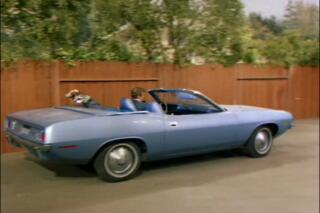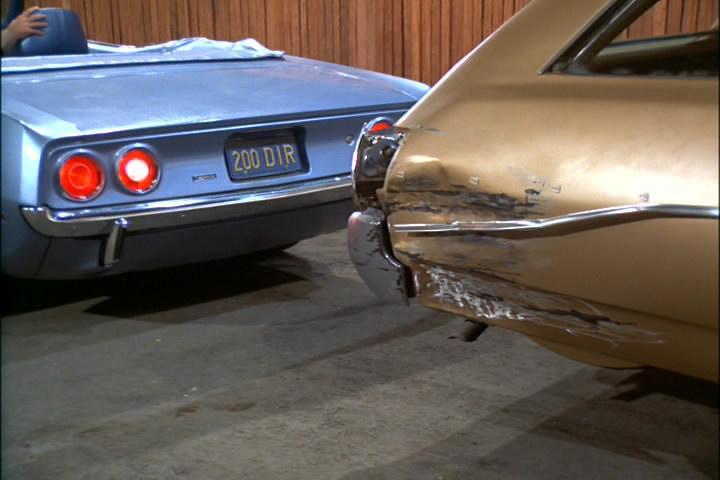The first image is the image on the left, the second image is the image on the right. For the images displayed, is the sentence "There is more than one person in one of the cars." factually correct? Answer yes or no. No. The first image is the image on the left, the second image is the image on the right. Considering the images on both sides, is "A man in a brown suit is standing." valid? Answer yes or no. No. 